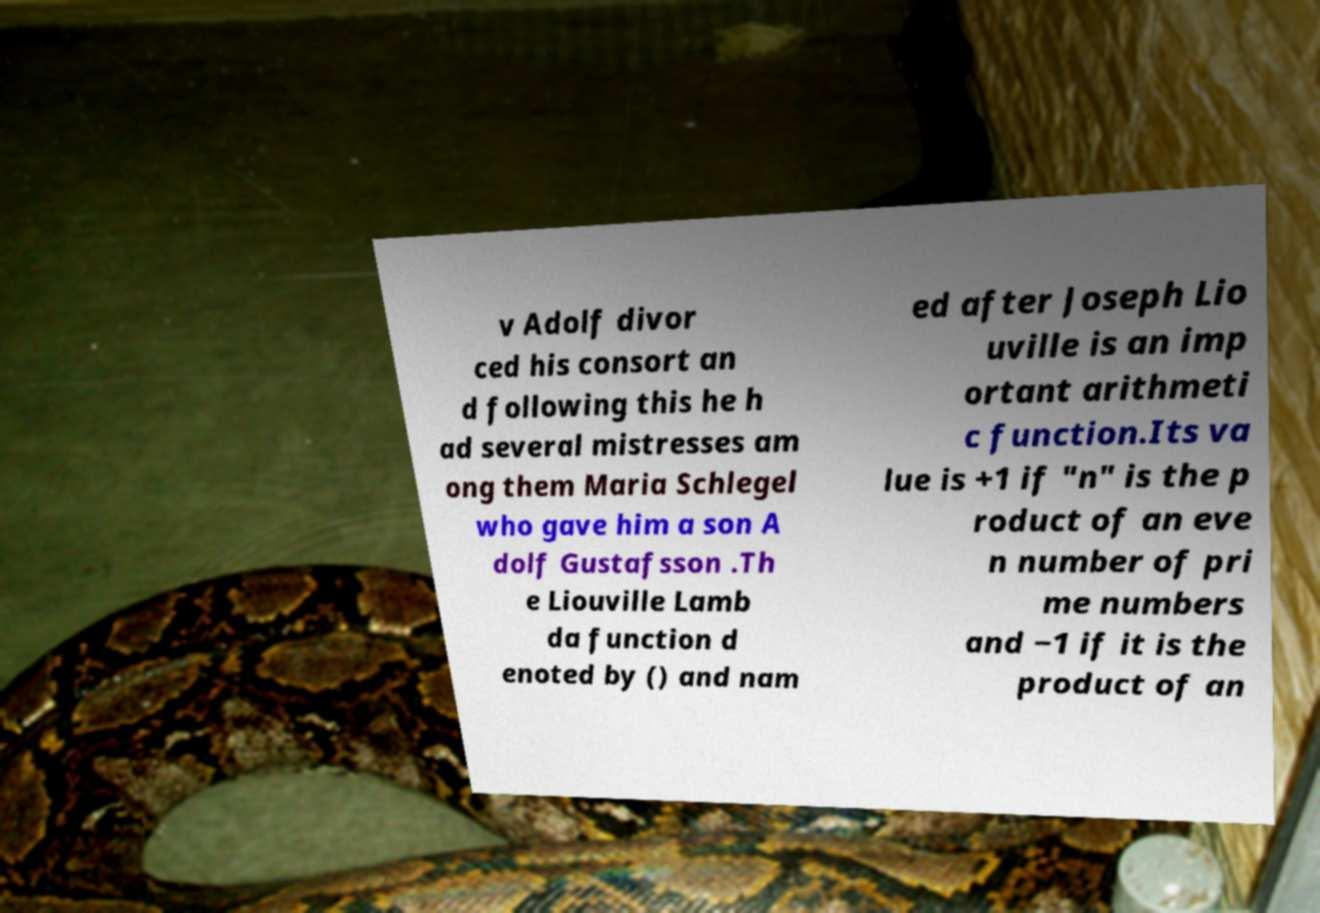What messages or text are displayed in this image? I need them in a readable, typed format. v Adolf divor ced his consort an d following this he h ad several mistresses am ong them Maria Schlegel who gave him a son A dolf Gustafsson .Th e Liouville Lamb da function d enoted by () and nam ed after Joseph Lio uville is an imp ortant arithmeti c function.Its va lue is +1 if "n" is the p roduct of an eve n number of pri me numbers and −1 if it is the product of an 